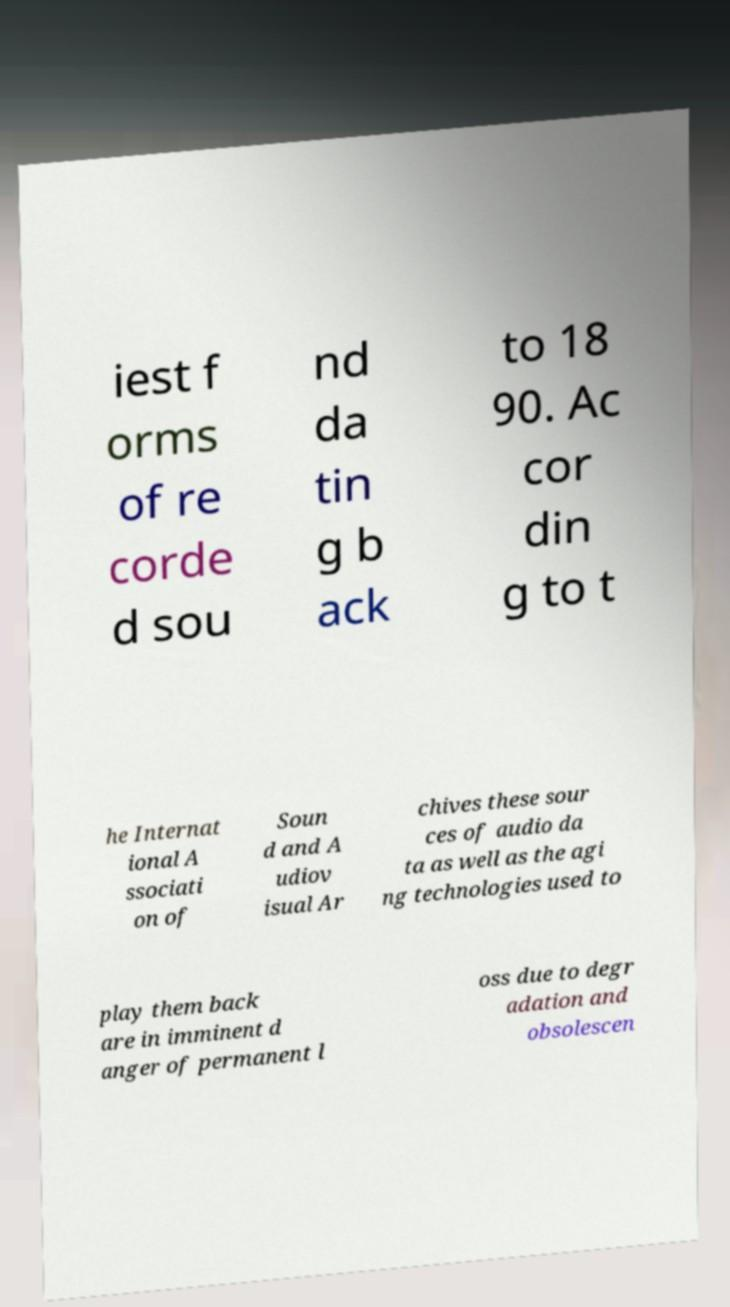Can you accurately transcribe the text from the provided image for me? iest f orms of re corde d sou nd da tin g b ack to 18 90. Ac cor din g to t he Internat ional A ssociati on of Soun d and A udiov isual Ar chives these sour ces of audio da ta as well as the agi ng technologies used to play them back are in imminent d anger of permanent l oss due to degr adation and obsolescen 